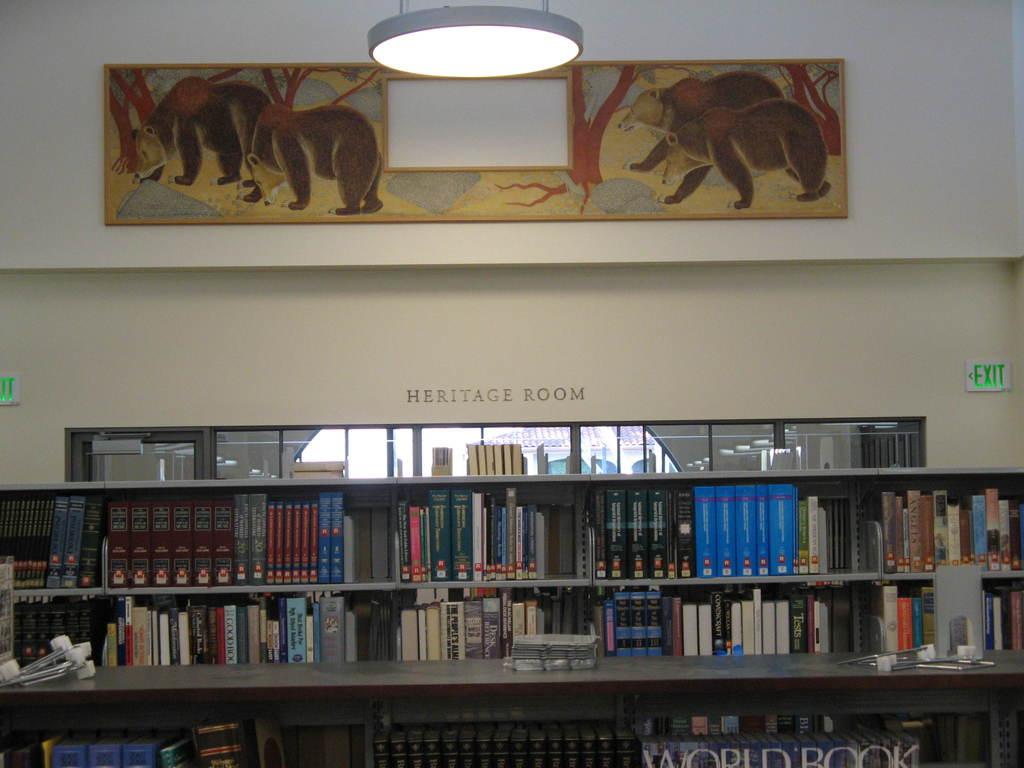What is the name of the next room over?
Your answer should be very brief. Heritage room. What is the book on the bottom right?
Your response must be concise. World book. 